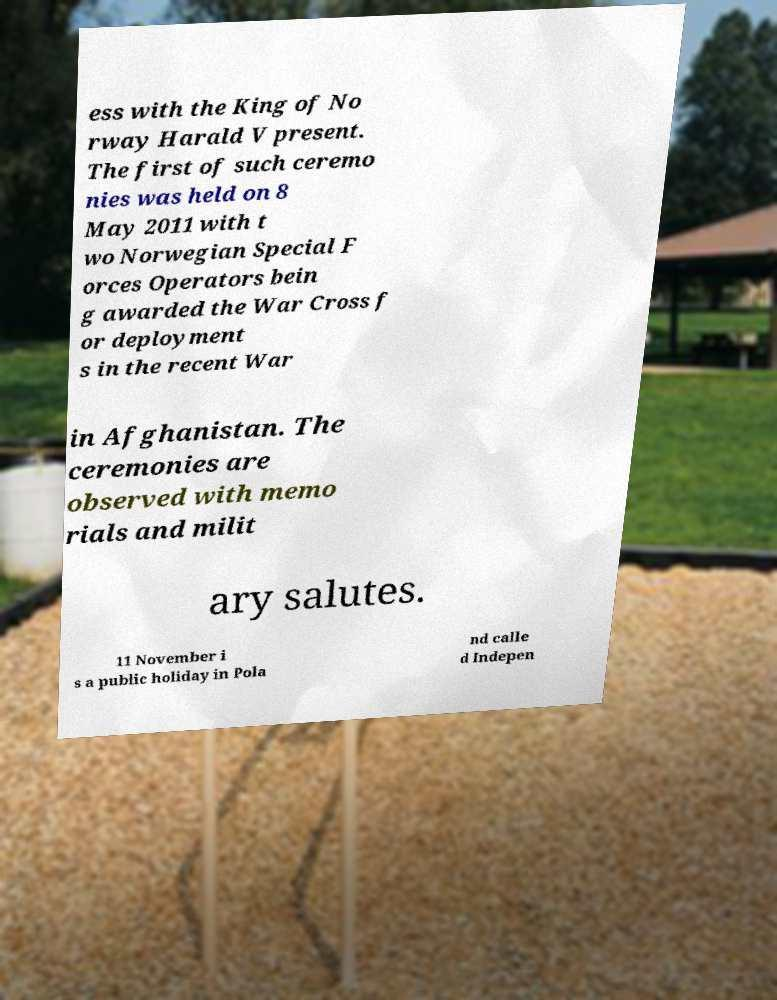Can you read and provide the text displayed in the image?This photo seems to have some interesting text. Can you extract and type it out for me? ess with the King of No rway Harald V present. The first of such ceremo nies was held on 8 May 2011 with t wo Norwegian Special F orces Operators bein g awarded the War Cross f or deployment s in the recent War in Afghanistan. The ceremonies are observed with memo rials and milit ary salutes. 11 November i s a public holiday in Pola nd calle d Indepen 